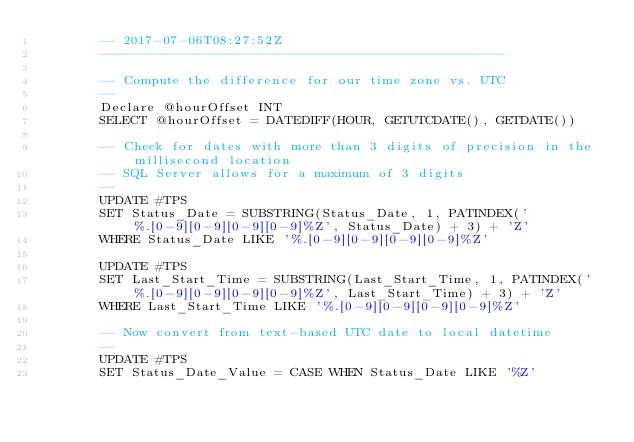<code> <loc_0><loc_0><loc_500><loc_500><_SQL_>        -- 2017-07-06T08:27:52Z
        ---------------------------------------------------

        -- Compute the difference for our time zone vs. UTC
        --
        Declare @hourOffset INT
        SELECT @hourOffset = DATEDIFF(HOUR, GETUTCDATE(), GETDATE())

        -- Check for dates with more than 3 digits of precision in the millisecond location
        -- SQL Server allows for a maximum of 3 digits
        --
        UPDATE #TPS
        SET Status_Date = SUBSTRING(Status_Date, 1, PATINDEX('%.[0-9][0-9][0-9][0-9]%Z', Status_Date) + 3) + 'Z'
        WHERE Status_Date LIKE '%.[0-9][0-9][0-9][0-9]%Z'
        
        UPDATE #TPS
        SET Last_Start_Time = SUBSTRING(Last_Start_Time, 1, PATINDEX('%.[0-9][0-9][0-9][0-9]%Z', Last_Start_Time) + 3) + 'Z'
        WHERE Last_Start_Time LIKE '%.[0-9][0-9][0-9][0-9]%Z'

        -- Now convert from text-based UTC date to local datetime
        --
        UPDATE #TPS
        SET Status_Date_Value = CASE WHEN Status_Date LIKE '%Z' </code> 